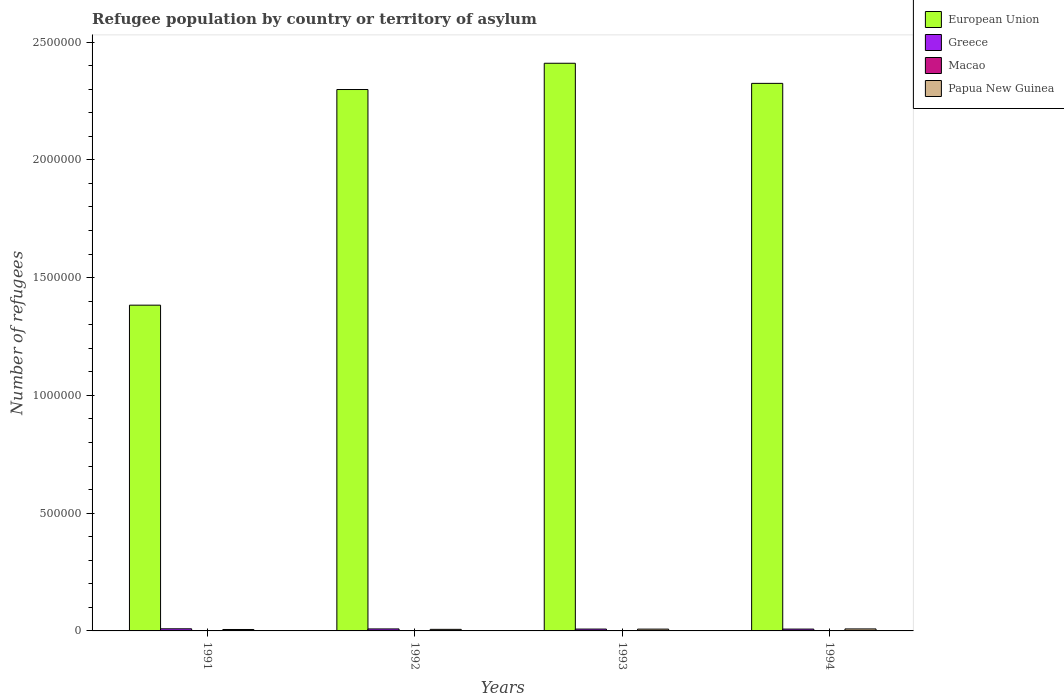How many different coloured bars are there?
Your response must be concise. 4. Are the number of bars per tick equal to the number of legend labels?
Offer a very short reply. Yes. Are the number of bars on each tick of the X-axis equal?
Offer a very short reply. Yes. How many bars are there on the 3rd tick from the right?
Your response must be concise. 4. What is the label of the 2nd group of bars from the left?
Offer a terse response. 1992. In how many cases, is the number of bars for a given year not equal to the number of legend labels?
Offer a terse response. 0. What is the number of refugees in Macao in 1992?
Keep it short and to the point. 15. Across all years, what is the maximum number of refugees in Greece?
Keep it short and to the point. 8989. Across all years, what is the minimum number of refugees in European Union?
Make the answer very short. 1.38e+06. In which year was the number of refugees in Macao maximum?
Your response must be concise. 1991. In which year was the number of refugees in Macao minimum?
Your answer should be very brief. 1994. What is the total number of refugees in Papua New Guinea in the graph?
Provide a short and direct response. 2.89e+04. What is the difference between the number of refugees in European Union in 1993 and that in 1994?
Offer a very short reply. 8.54e+04. What is the difference between the number of refugees in Papua New Guinea in 1992 and the number of refugees in Macao in 1991?
Keep it short and to the point. 6570. What is the average number of refugees in Greece per year?
Provide a succinct answer. 8275.5. In the year 1992, what is the difference between the number of refugees in European Union and number of refugees in Greece?
Your answer should be very brief. 2.29e+06. What is the ratio of the number of refugees in Greece in 1992 to that in 1994?
Provide a short and direct response. 1.09. What is the difference between the highest and the second highest number of refugees in Papua New Guinea?
Offer a terse response. 791. What is the difference between the highest and the lowest number of refugees in European Union?
Ensure brevity in your answer.  1.03e+06. What does the 1st bar from the right in 1991 represents?
Give a very brief answer. Papua New Guinea. Is it the case that in every year, the sum of the number of refugees in Greece and number of refugees in Papua New Guinea is greater than the number of refugees in European Union?
Offer a very short reply. No. How many years are there in the graph?
Keep it short and to the point. 4. What is the title of the graph?
Ensure brevity in your answer.  Refugee population by country or territory of asylum. Does "Dominica" appear as one of the legend labels in the graph?
Provide a succinct answer. No. What is the label or title of the X-axis?
Keep it short and to the point. Years. What is the label or title of the Y-axis?
Offer a very short reply. Number of refugees. What is the Number of refugees of European Union in 1991?
Your answer should be very brief. 1.38e+06. What is the Number of refugees in Greece in 1991?
Ensure brevity in your answer.  8989. What is the Number of refugees in Macao in 1991?
Give a very brief answer. 116. What is the Number of refugees in Papua New Guinea in 1991?
Ensure brevity in your answer.  6098. What is the Number of refugees of European Union in 1992?
Keep it short and to the point. 2.30e+06. What is the Number of refugees in Greece in 1992?
Your answer should be compact. 8456. What is the Number of refugees in Papua New Guinea in 1992?
Your response must be concise. 6686. What is the Number of refugees of European Union in 1993?
Offer a very short reply. 2.41e+06. What is the Number of refugees in Greece in 1993?
Your answer should be compact. 7873. What is the Number of refugees of Macao in 1993?
Offer a terse response. 10. What is the Number of refugees of Papua New Guinea in 1993?
Your response must be concise. 7670. What is the Number of refugees of European Union in 1994?
Your response must be concise. 2.32e+06. What is the Number of refugees of Greece in 1994?
Give a very brief answer. 7784. What is the Number of refugees in Macao in 1994?
Give a very brief answer. 9. What is the Number of refugees of Papua New Guinea in 1994?
Your response must be concise. 8461. Across all years, what is the maximum Number of refugees in European Union?
Ensure brevity in your answer.  2.41e+06. Across all years, what is the maximum Number of refugees in Greece?
Offer a terse response. 8989. Across all years, what is the maximum Number of refugees of Macao?
Offer a very short reply. 116. Across all years, what is the maximum Number of refugees of Papua New Guinea?
Offer a terse response. 8461. Across all years, what is the minimum Number of refugees of European Union?
Keep it short and to the point. 1.38e+06. Across all years, what is the minimum Number of refugees in Greece?
Offer a very short reply. 7784. Across all years, what is the minimum Number of refugees of Papua New Guinea?
Provide a short and direct response. 6098. What is the total Number of refugees in European Union in the graph?
Your answer should be very brief. 8.42e+06. What is the total Number of refugees of Greece in the graph?
Provide a succinct answer. 3.31e+04. What is the total Number of refugees in Macao in the graph?
Give a very brief answer. 150. What is the total Number of refugees in Papua New Guinea in the graph?
Make the answer very short. 2.89e+04. What is the difference between the Number of refugees of European Union in 1991 and that in 1992?
Offer a very short reply. -9.15e+05. What is the difference between the Number of refugees in Greece in 1991 and that in 1992?
Your answer should be very brief. 533. What is the difference between the Number of refugees of Macao in 1991 and that in 1992?
Your answer should be very brief. 101. What is the difference between the Number of refugees in Papua New Guinea in 1991 and that in 1992?
Make the answer very short. -588. What is the difference between the Number of refugees in European Union in 1991 and that in 1993?
Keep it short and to the point. -1.03e+06. What is the difference between the Number of refugees in Greece in 1991 and that in 1993?
Provide a succinct answer. 1116. What is the difference between the Number of refugees of Macao in 1991 and that in 1993?
Provide a short and direct response. 106. What is the difference between the Number of refugees of Papua New Guinea in 1991 and that in 1993?
Offer a terse response. -1572. What is the difference between the Number of refugees of European Union in 1991 and that in 1994?
Provide a short and direct response. -9.42e+05. What is the difference between the Number of refugees of Greece in 1991 and that in 1994?
Provide a short and direct response. 1205. What is the difference between the Number of refugees of Macao in 1991 and that in 1994?
Your answer should be compact. 107. What is the difference between the Number of refugees of Papua New Guinea in 1991 and that in 1994?
Ensure brevity in your answer.  -2363. What is the difference between the Number of refugees of European Union in 1992 and that in 1993?
Offer a very short reply. -1.11e+05. What is the difference between the Number of refugees of Greece in 1992 and that in 1993?
Keep it short and to the point. 583. What is the difference between the Number of refugees in Papua New Guinea in 1992 and that in 1993?
Give a very brief answer. -984. What is the difference between the Number of refugees in European Union in 1992 and that in 1994?
Offer a very short reply. -2.61e+04. What is the difference between the Number of refugees of Greece in 1992 and that in 1994?
Ensure brevity in your answer.  672. What is the difference between the Number of refugees of Macao in 1992 and that in 1994?
Offer a terse response. 6. What is the difference between the Number of refugees of Papua New Guinea in 1992 and that in 1994?
Provide a short and direct response. -1775. What is the difference between the Number of refugees of European Union in 1993 and that in 1994?
Offer a very short reply. 8.54e+04. What is the difference between the Number of refugees of Greece in 1993 and that in 1994?
Keep it short and to the point. 89. What is the difference between the Number of refugees of Macao in 1993 and that in 1994?
Your answer should be compact. 1. What is the difference between the Number of refugees of Papua New Guinea in 1993 and that in 1994?
Keep it short and to the point. -791. What is the difference between the Number of refugees of European Union in 1991 and the Number of refugees of Greece in 1992?
Provide a short and direct response. 1.37e+06. What is the difference between the Number of refugees of European Union in 1991 and the Number of refugees of Macao in 1992?
Your response must be concise. 1.38e+06. What is the difference between the Number of refugees in European Union in 1991 and the Number of refugees in Papua New Guinea in 1992?
Provide a short and direct response. 1.38e+06. What is the difference between the Number of refugees of Greece in 1991 and the Number of refugees of Macao in 1992?
Provide a succinct answer. 8974. What is the difference between the Number of refugees of Greece in 1991 and the Number of refugees of Papua New Guinea in 1992?
Your answer should be compact. 2303. What is the difference between the Number of refugees in Macao in 1991 and the Number of refugees in Papua New Guinea in 1992?
Offer a terse response. -6570. What is the difference between the Number of refugees in European Union in 1991 and the Number of refugees in Greece in 1993?
Offer a very short reply. 1.38e+06. What is the difference between the Number of refugees of European Union in 1991 and the Number of refugees of Macao in 1993?
Provide a short and direct response. 1.38e+06. What is the difference between the Number of refugees of European Union in 1991 and the Number of refugees of Papua New Guinea in 1993?
Keep it short and to the point. 1.38e+06. What is the difference between the Number of refugees in Greece in 1991 and the Number of refugees in Macao in 1993?
Give a very brief answer. 8979. What is the difference between the Number of refugees of Greece in 1991 and the Number of refugees of Papua New Guinea in 1993?
Provide a succinct answer. 1319. What is the difference between the Number of refugees of Macao in 1991 and the Number of refugees of Papua New Guinea in 1993?
Give a very brief answer. -7554. What is the difference between the Number of refugees of European Union in 1991 and the Number of refugees of Greece in 1994?
Offer a very short reply. 1.38e+06. What is the difference between the Number of refugees in European Union in 1991 and the Number of refugees in Macao in 1994?
Offer a terse response. 1.38e+06. What is the difference between the Number of refugees of European Union in 1991 and the Number of refugees of Papua New Guinea in 1994?
Give a very brief answer. 1.37e+06. What is the difference between the Number of refugees in Greece in 1991 and the Number of refugees in Macao in 1994?
Offer a very short reply. 8980. What is the difference between the Number of refugees of Greece in 1991 and the Number of refugees of Papua New Guinea in 1994?
Your answer should be compact. 528. What is the difference between the Number of refugees of Macao in 1991 and the Number of refugees of Papua New Guinea in 1994?
Make the answer very short. -8345. What is the difference between the Number of refugees of European Union in 1992 and the Number of refugees of Greece in 1993?
Make the answer very short. 2.29e+06. What is the difference between the Number of refugees of European Union in 1992 and the Number of refugees of Macao in 1993?
Your response must be concise. 2.30e+06. What is the difference between the Number of refugees of European Union in 1992 and the Number of refugees of Papua New Guinea in 1993?
Offer a very short reply. 2.29e+06. What is the difference between the Number of refugees of Greece in 1992 and the Number of refugees of Macao in 1993?
Make the answer very short. 8446. What is the difference between the Number of refugees of Greece in 1992 and the Number of refugees of Papua New Guinea in 1993?
Offer a terse response. 786. What is the difference between the Number of refugees of Macao in 1992 and the Number of refugees of Papua New Guinea in 1993?
Keep it short and to the point. -7655. What is the difference between the Number of refugees in European Union in 1992 and the Number of refugees in Greece in 1994?
Offer a terse response. 2.29e+06. What is the difference between the Number of refugees of European Union in 1992 and the Number of refugees of Macao in 1994?
Provide a succinct answer. 2.30e+06. What is the difference between the Number of refugees of European Union in 1992 and the Number of refugees of Papua New Guinea in 1994?
Your answer should be compact. 2.29e+06. What is the difference between the Number of refugees of Greece in 1992 and the Number of refugees of Macao in 1994?
Offer a terse response. 8447. What is the difference between the Number of refugees in Greece in 1992 and the Number of refugees in Papua New Guinea in 1994?
Offer a terse response. -5. What is the difference between the Number of refugees in Macao in 1992 and the Number of refugees in Papua New Guinea in 1994?
Provide a short and direct response. -8446. What is the difference between the Number of refugees in European Union in 1993 and the Number of refugees in Greece in 1994?
Keep it short and to the point. 2.40e+06. What is the difference between the Number of refugees of European Union in 1993 and the Number of refugees of Macao in 1994?
Your response must be concise. 2.41e+06. What is the difference between the Number of refugees in European Union in 1993 and the Number of refugees in Papua New Guinea in 1994?
Your answer should be compact. 2.40e+06. What is the difference between the Number of refugees of Greece in 1993 and the Number of refugees of Macao in 1994?
Your answer should be compact. 7864. What is the difference between the Number of refugees of Greece in 1993 and the Number of refugees of Papua New Guinea in 1994?
Offer a very short reply. -588. What is the difference between the Number of refugees of Macao in 1993 and the Number of refugees of Papua New Guinea in 1994?
Offer a terse response. -8451. What is the average Number of refugees in European Union per year?
Make the answer very short. 2.10e+06. What is the average Number of refugees of Greece per year?
Ensure brevity in your answer.  8275.5. What is the average Number of refugees in Macao per year?
Offer a terse response. 37.5. What is the average Number of refugees in Papua New Guinea per year?
Offer a very short reply. 7228.75. In the year 1991, what is the difference between the Number of refugees in European Union and Number of refugees in Greece?
Your answer should be compact. 1.37e+06. In the year 1991, what is the difference between the Number of refugees in European Union and Number of refugees in Macao?
Provide a succinct answer. 1.38e+06. In the year 1991, what is the difference between the Number of refugees of European Union and Number of refugees of Papua New Guinea?
Your answer should be compact. 1.38e+06. In the year 1991, what is the difference between the Number of refugees in Greece and Number of refugees in Macao?
Your answer should be compact. 8873. In the year 1991, what is the difference between the Number of refugees in Greece and Number of refugees in Papua New Guinea?
Give a very brief answer. 2891. In the year 1991, what is the difference between the Number of refugees in Macao and Number of refugees in Papua New Guinea?
Offer a terse response. -5982. In the year 1992, what is the difference between the Number of refugees in European Union and Number of refugees in Greece?
Ensure brevity in your answer.  2.29e+06. In the year 1992, what is the difference between the Number of refugees in European Union and Number of refugees in Macao?
Keep it short and to the point. 2.30e+06. In the year 1992, what is the difference between the Number of refugees of European Union and Number of refugees of Papua New Guinea?
Make the answer very short. 2.29e+06. In the year 1992, what is the difference between the Number of refugees of Greece and Number of refugees of Macao?
Offer a very short reply. 8441. In the year 1992, what is the difference between the Number of refugees in Greece and Number of refugees in Papua New Guinea?
Provide a succinct answer. 1770. In the year 1992, what is the difference between the Number of refugees of Macao and Number of refugees of Papua New Guinea?
Make the answer very short. -6671. In the year 1993, what is the difference between the Number of refugees in European Union and Number of refugees in Greece?
Offer a terse response. 2.40e+06. In the year 1993, what is the difference between the Number of refugees of European Union and Number of refugees of Macao?
Offer a terse response. 2.41e+06. In the year 1993, what is the difference between the Number of refugees of European Union and Number of refugees of Papua New Guinea?
Give a very brief answer. 2.40e+06. In the year 1993, what is the difference between the Number of refugees in Greece and Number of refugees in Macao?
Ensure brevity in your answer.  7863. In the year 1993, what is the difference between the Number of refugees in Greece and Number of refugees in Papua New Guinea?
Your response must be concise. 203. In the year 1993, what is the difference between the Number of refugees of Macao and Number of refugees of Papua New Guinea?
Ensure brevity in your answer.  -7660. In the year 1994, what is the difference between the Number of refugees of European Union and Number of refugees of Greece?
Your response must be concise. 2.32e+06. In the year 1994, what is the difference between the Number of refugees in European Union and Number of refugees in Macao?
Your answer should be compact. 2.32e+06. In the year 1994, what is the difference between the Number of refugees of European Union and Number of refugees of Papua New Guinea?
Ensure brevity in your answer.  2.32e+06. In the year 1994, what is the difference between the Number of refugees of Greece and Number of refugees of Macao?
Offer a terse response. 7775. In the year 1994, what is the difference between the Number of refugees in Greece and Number of refugees in Papua New Guinea?
Keep it short and to the point. -677. In the year 1994, what is the difference between the Number of refugees of Macao and Number of refugees of Papua New Guinea?
Your answer should be very brief. -8452. What is the ratio of the Number of refugees in European Union in 1991 to that in 1992?
Make the answer very short. 0.6. What is the ratio of the Number of refugees in Greece in 1991 to that in 1992?
Make the answer very short. 1.06. What is the ratio of the Number of refugees in Macao in 1991 to that in 1992?
Your answer should be very brief. 7.73. What is the ratio of the Number of refugees in Papua New Guinea in 1991 to that in 1992?
Your answer should be compact. 0.91. What is the ratio of the Number of refugees in European Union in 1991 to that in 1993?
Your response must be concise. 0.57. What is the ratio of the Number of refugees in Greece in 1991 to that in 1993?
Make the answer very short. 1.14. What is the ratio of the Number of refugees in Macao in 1991 to that in 1993?
Offer a very short reply. 11.6. What is the ratio of the Number of refugees in Papua New Guinea in 1991 to that in 1993?
Your response must be concise. 0.8. What is the ratio of the Number of refugees of European Union in 1991 to that in 1994?
Make the answer very short. 0.59. What is the ratio of the Number of refugees in Greece in 1991 to that in 1994?
Give a very brief answer. 1.15. What is the ratio of the Number of refugees in Macao in 1991 to that in 1994?
Offer a terse response. 12.89. What is the ratio of the Number of refugees of Papua New Guinea in 1991 to that in 1994?
Make the answer very short. 0.72. What is the ratio of the Number of refugees of European Union in 1992 to that in 1993?
Make the answer very short. 0.95. What is the ratio of the Number of refugees of Greece in 1992 to that in 1993?
Keep it short and to the point. 1.07. What is the ratio of the Number of refugees of Macao in 1992 to that in 1993?
Keep it short and to the point. 1.5. What is the ratio of the Number of refugees in Papua New Guinea in 1992 to that in 1993?
Your answer should be compact. 0.87. What is the ratio of the Number of refugees in Greece in 1992 to that in 1994?
Your answer should be compact. 1.09. What is the ratio of the Number of refugees of Papua New Guinea in 1992 to that in 1994?
Offer a very short reply. 0.79. What is the ratio of the Number of refugees in European Union in 1993 to that in 1994?
Give a very brief answer. 1.04. What is the ratio of the Number of refugees in Greece in 1993 to that in 1994?
Ensure brevity in your answer.  1.01. What is the ratio of the Number of refugees of Papua New Guinea in 1993 to that in 1994?
Make the answer very short. 0.91. What is the difference between the highest and the second highest Number of refugees in European Union?
Provide a succinct answer. 8.54e+04. What is the difference between the highest and the second highest Number of refugees of Greece?
Give a very brief answer. 533. What is the difference between the highest and the second highest Number of refugees of Macao?
Offer a terse response. 101. What is the difference between the highest and the second highest Number of refugees in Papua New Guinea?
Offer a very short reply. 791. What is the difference between the highest and the lowest Number of refugees of European Union?
Keep it short and to the point. 1.03e+06. What is the difference between the highest and the lowest Number of refugees in Greece?
Keep it short and to the point. 1205. What is the difference between the highest and the lowest Number of refugees in Macao?
Provide a succinct answer. 107. What is the difference between the highest and the lowest Number of refugees of Papua New Guinea?
Your answer should be very brief. 2363. 